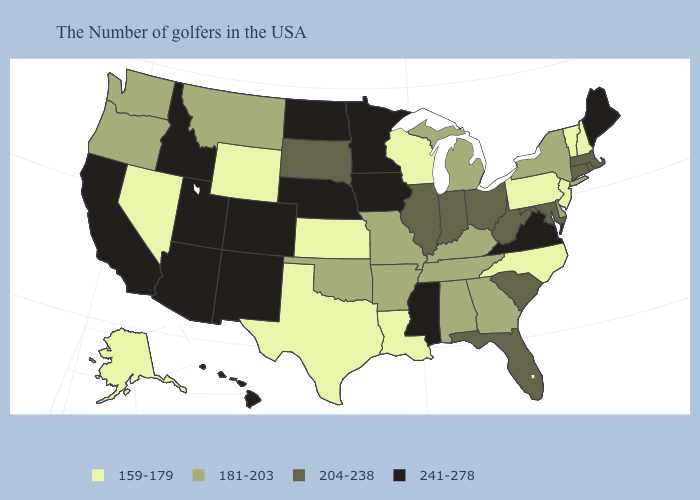What is the lowest value in the West?
Write a very short answer. 159-179. What is the highest value in the USA?
Keep it brief. 241-278. Does the map have missing data?
Write a very short answer. No. Among the states that border Indiana , which have the highest value?
Keep it brief. Ohio, Illinois. What is the lowest value in states that border Connecticut?
Give a very brief answer. 181-203. Does the first symbol in the legend represent the smallest category?
Write a very short answer. Yes. Name the states that have a value in the range 159-179?
Give a very brief answer. New Hampshire, Vermont, New Jersey, Pennsylvania, North Carolina, Wisconsin, Louisiana, Kansas, Texas, Wyoming, Nevada, Alaska. What is the value of Iowa?
Write a very short answer. 241-278. What is the value of Pennsylvania?
Short answer required. 159-179. What is the highest value in states that border New Jersey?
Write a very short answer. 181-203. Does Connecticut have the same value as South Carolina?
Keep it brief. Yes. Which states have the lowest value in the Northeast?
Answer briefly. New Hampshire, Vermont, New Jersey, Pennsylvania. Does Nebraska have the same value as Ohio?
Answer briefly. No. Does Mississippi have the highest value in the South?
Keep it brief. Yes. 